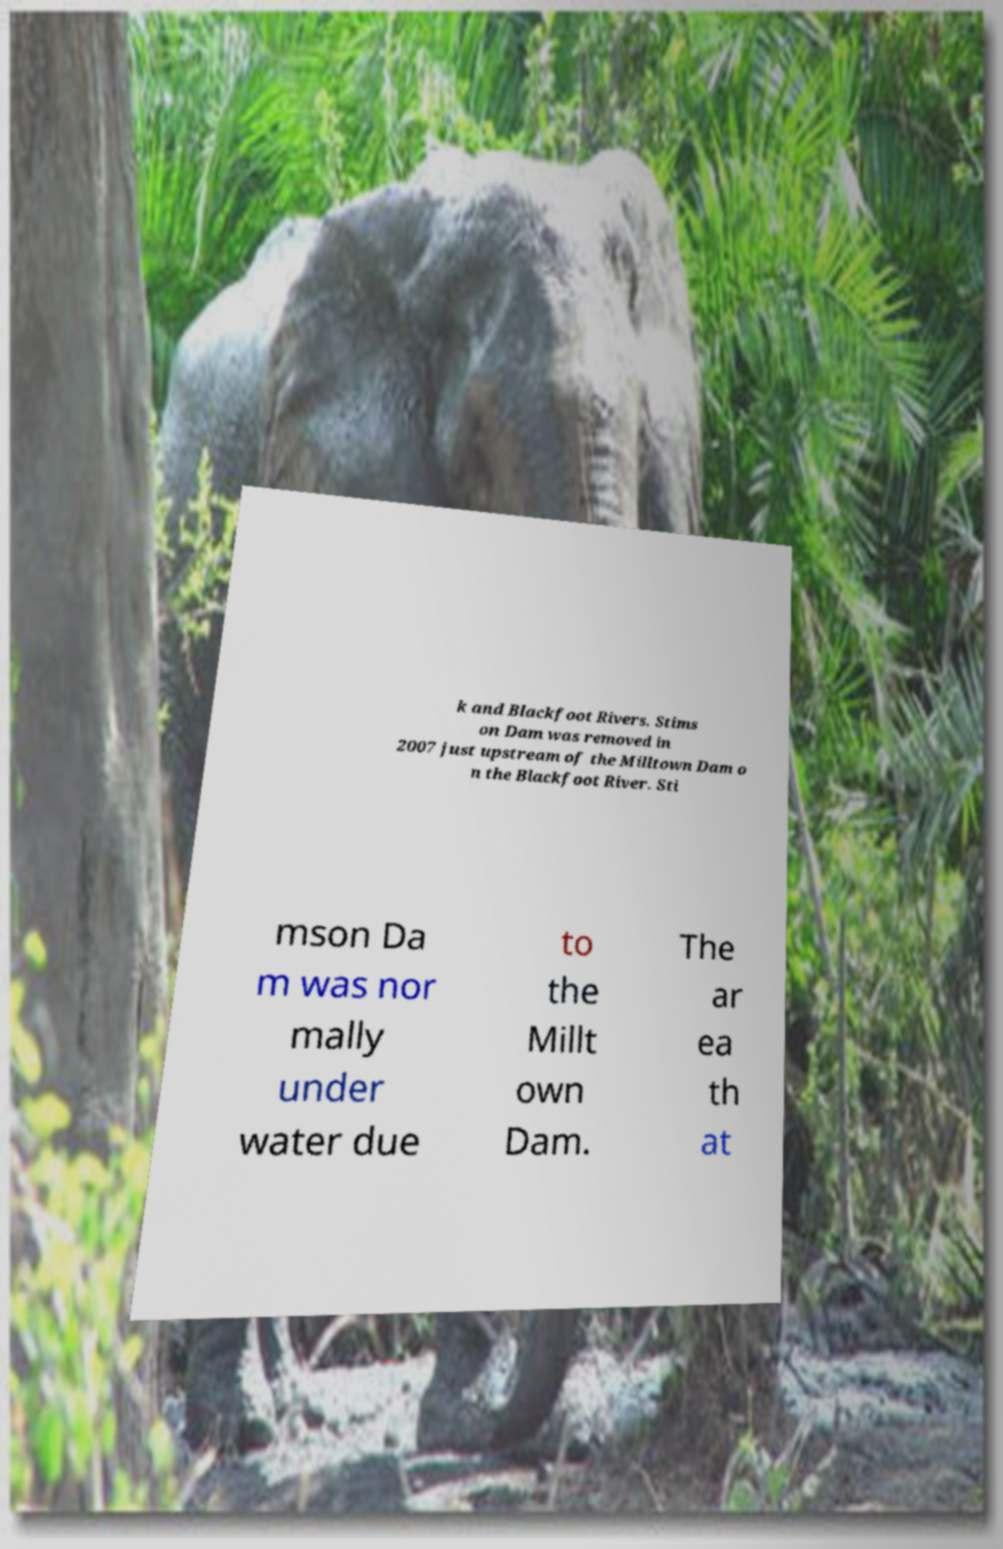Can you read and provide the text displayed in the image?This photo seems to have some interesting text. Can you extract and type it out for me? k and Blackfoot Rivers. Stims on Dam was removed in 2007 just upstream of the Milltown Dam o n the Blackfoot River. Sti mson Da m was nor mally under water due to the Millt own Dam. The ar ea th at 